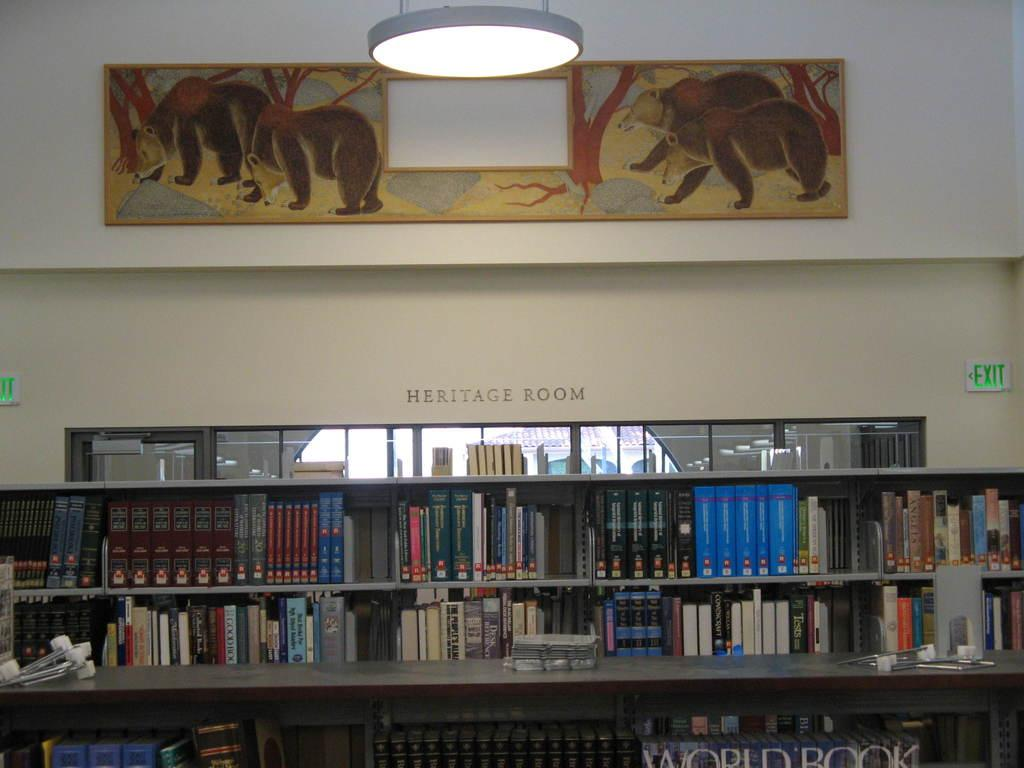<image>
Write a terse but informative summary of the picture. Just inside the Heritage Room at the library there is a full World Book encyclopedia set. 